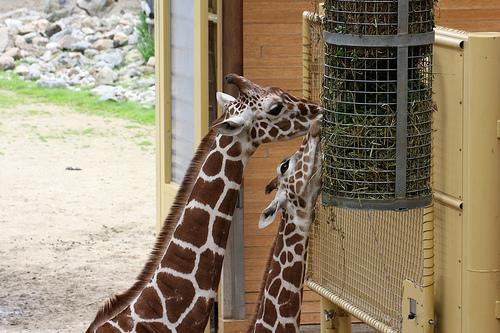Identify the number, appearance, and activity of the giraffes in the image. There are two giraffes, brown and white in color, eating grass from a metal round feeder. Mention the difference between the two giraffes and their activity. One giraffe is smaller than the other, and the smallest giraffe is reaching its head up for the food. Tell me about the giraffes' physical features and the action they are performing. The giraffes have long necks and are brown and white; they are reaching their heads up to eat from a metal food basket. What kind of environment are the giraffes in and what is the state of the entrance? The giraffes are in a wooden building with an open door, letting light in; they are surrounded by sandy ground, some grass, and a pile of rocks. Discuss the size and colors of the two giraffes and specify their ages. The two giraffes are brown and white, with one being smaller than the other; they are both very young. Describe the container the giraffes are eating from and how it is positioned. The giraffes eat from a metal basket, which is connected to a yellow metal wall and filled with hay. Examine the features of the building and the way light enters it. The building is made of wood, and light is coming in through the open door. Explain the characteristics of the fence and its relation to the giraffes' activity. The fence is metallic and functions as a cage full of grass, keeping the giraffes inside while they eat. Describe the giraffe's ears and point out any notable visual features related to their eyes. Both giraffes have ears visible, and the right eye of one giraffe is accentuated with a white line around it. What is the composition of the ground and the state of the grass in the image? The ground is sandy with some green grass and a pile of rocks scattered around it. Can you spot the pink elephant hidden behind the giraffes? Look near the left corner of the image. No, it's not mentioned in the image. 